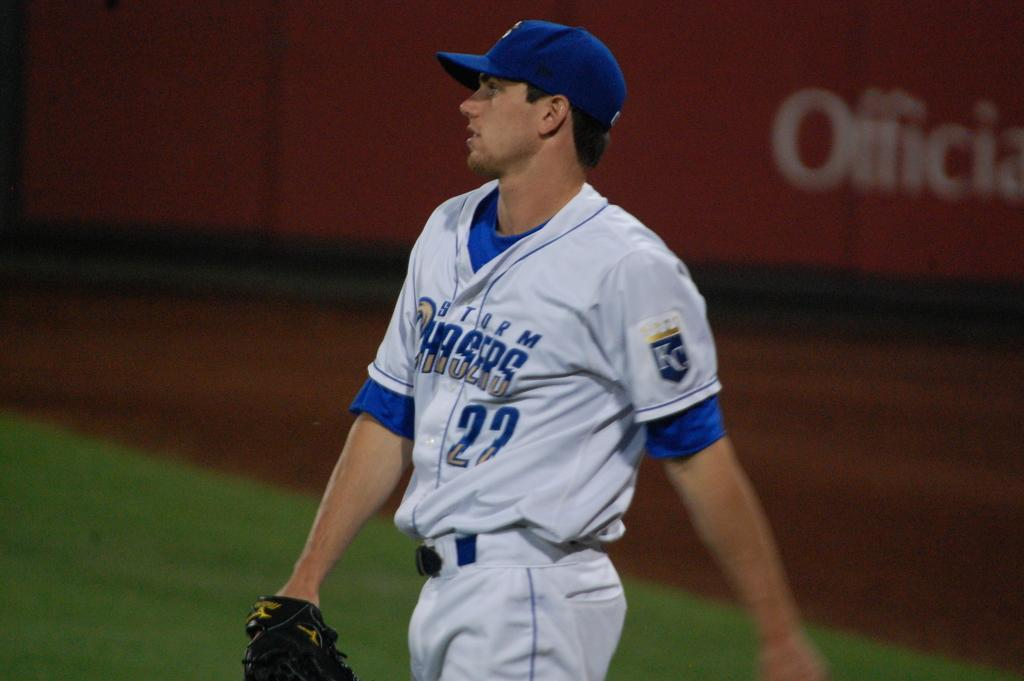<image>
Present a compact description of the photo's key features. Baseball player wearing a number 23 jersey which says Chargers. 